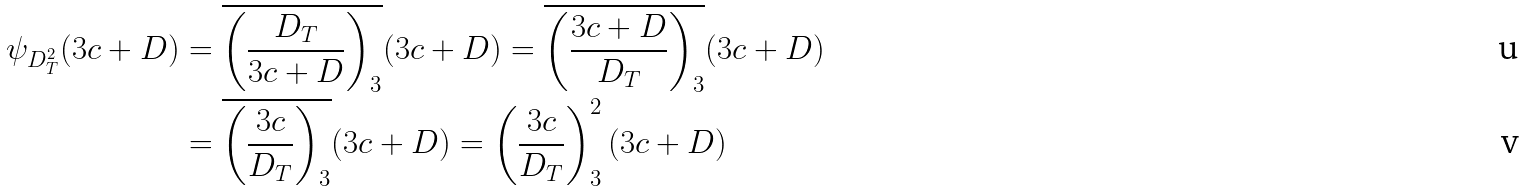<formula> <loc_0><loc_0><loc_500><loc_500>\psi _ { D _ { T } ^ { 2 } } ( 3 c + D ) & = \overline { \left ( \frac { D _ { T } } { 3 c + D } \right ) _ { 3 } } ( 3 c + D ) = \overline { \left ( \frac { 3 c + D } { D _ { T } } \right ) _ { 3 } } ( 3 c + D ) \\ & = \overline { \left ( \frac { 3 c } { D _ { T } } \right ) _ { 3 } } ( 3 c + D ) = \left ( \frac { 3 c } { D _ { T } } \right ) _ { 3 } ^ { 2 } ( 3 c + D )</formula> 